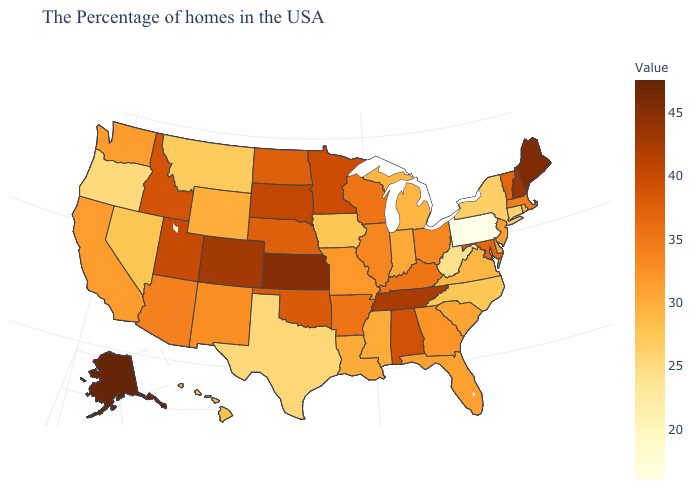Is the legend a continuous bar?
Give a very brief answer. Yes. Does Pennsylvania have the lowest value in the USA?
Be succinct. Yes. Does Wisconsin have a lower value than Delaware?
Quick response, please. No. Among the states that border North Carolina , does Tennessee have the highest value?
Answer briefly. Yes. Which states have the highest value in the USA?
Short answer required. Alaska. Among the states that border Washington , does Idaho have the lowest value?
Write a very short answer. No. 